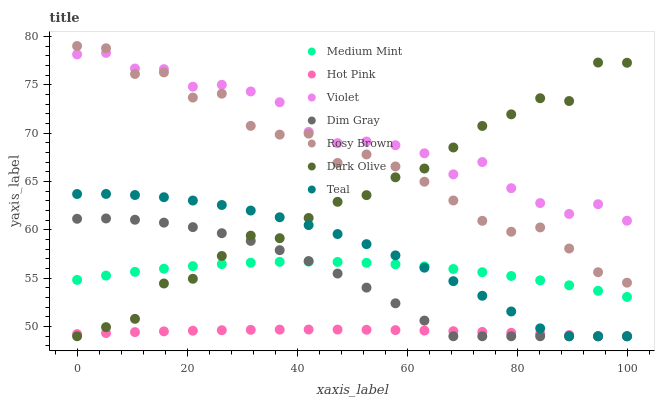Does Hot Pink have the minimum area under the curve?
Answer yes or no. Yes. Does Violet have the maximum area under the curve?
Answer yes or no. Yes. Does Dim Gray have the minimum area under the curve?
Answer yes or no. No. Does Dim Gray have the maximum area under the curve?
Answer yes or no. No. Is Hot Pink the smoothest?
Answer yes or no. Yes. Is Rosy Brown the roughest?
Answer yes or no. Yes. Is Dim Gray the smoothest?
Answer yes or no. No. Is Dim Gray the roughest?
Answer yes or no. No. Does Dim Gray have the lowest value?
Answer yes or no. Yes. Does Violet have the lowest value?
Answer yes or no. No. Does Rosy Brown have the highest value?
Answer yes or no. Yes. Does Dim Gray have the highest value?
Answer yes or no. No. Is Dim Gray less than Violet?
Answer yes or no. Yes. Is Violet greater than Dim Gray?
Answer yes or no. Yes. Does Dim Gray intersect Medium Mint?
Answer yes or no. Yes. Is Dim Gray less than Medium Mint?
Answer yes or no. No. Is Dim Gray greater than Medium Mint?
Answer yes or no. No. Does Dim Gray intersect Violet?
Answer yes or no. No. 